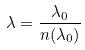<formula> <loc_0><loc_0><loc_500><loc_500>\lambda = \frac { \lambda _ { 0 } } { n ( \lambda _ { 0 } ) }</formula> 